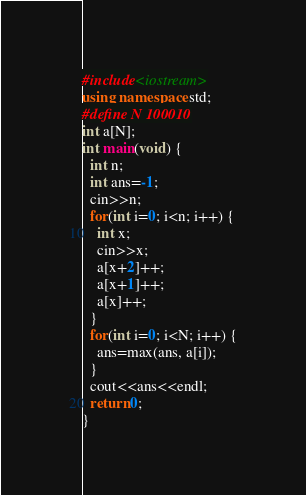<code> <loc_0><loc_0><loc_500><loc_500><_C++_>#include<iostream>
using namespace std;
#define N 100010
int a[N];
int main(void) {
  int n;
  int ans=-1;
  cin>>n;
  for(int i=0; i<n; i++) {
    int x;
    cin>>x;
    a[x+2]++;
    a[x+1]++;
    a[x]++;
  }
  for(int i=0; i<N; i++) {
    ans=max(ans, a[i]);
  }
  cout<<ans<<endl;
  return 0;
}
</code> 